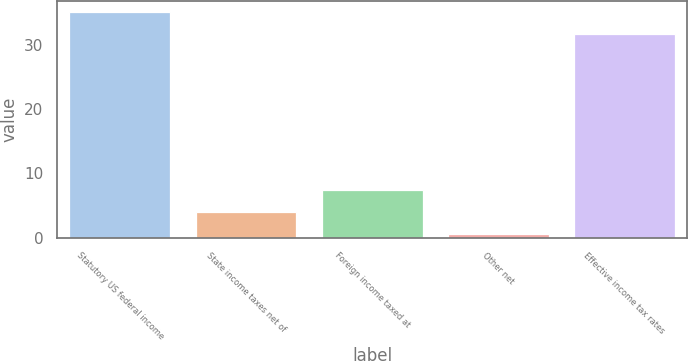Convert chart. <chart><loc_0><loc_0><loc_500><loc_500><bar_chart><fcel>Statutory US federal income<fcel>State income taxes net of<fcel>Foreign income taxed at<fcel>Other net<fcel>Effective income tax rates<nl><fcel>35.15<fcel>3.95<fcel>7.4<fcel>0.5<fcel>31.7<nl></chart> 